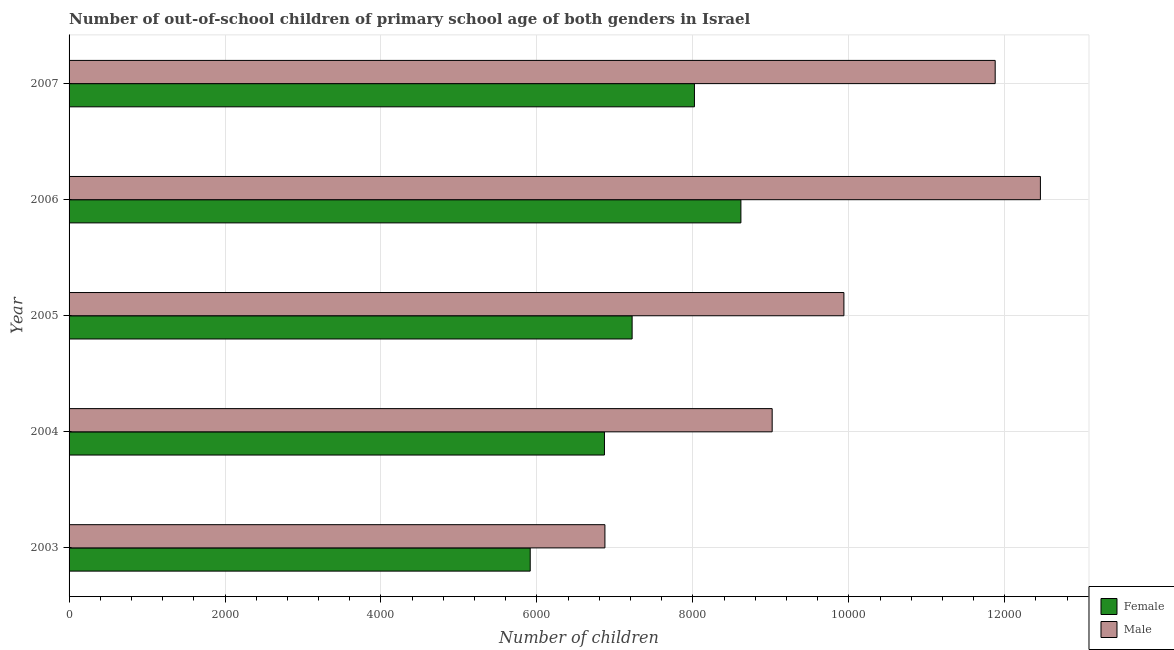Are the number of bars per tick equal to the number of legend labels?
Your response must be concise. Yes. Are the number of bars on each tick of the Y-axis equal?
Your answer should be very brief. Yes. How many bars are there on the 1st tick from the bottom?
Make the answer very short. 2. What is the label of the 3rd group of bars from the top?
Your answer should be very brief. 2005. What is the number of male out-of-school students in 2006?
Your response must be concise. 1.25e+04. Across all years, what is the maximum number of female out-of-school students?
Provide a short and direct response. 8616. Across all years, what is the minimum number of male out-of-school students?
Offer a terse response. 6872. In which year was the number of female out-of-school students maximum?
Give a very brief answer. 2006. What is the total number of female out-of-school students in the graph?
Your answer should be compact. 3.66e+04. What is the difference between the number of male out-of-school students in 2005 and that in 2006?
Offer a terse response. -2520. What is the difference between the number of male out-of-school students in 2005 and the number of female out-of-school students in 2007?
Keep it short and to the point. 1917. What is the average number of female out-of-school students per year?
Your answer should be very brief. 7327.4. In the year 2003, what is the difference between the number of female out-of-school students and number of male out-of-school students?
Offer a terse response. -958. What is the ratio of the number of female out-of-school students in 2005 to that in 2006?
Provide a succinct answer. 0.84. What is the difference between the highest and the second highest number of male out-of-school students?
Give a very brief answer. 580. What is the difference between the highest and the lowest number of female out-of-school students?
Keep it short and to the point. 2702. In how many years, is the number of female out-of-school students greater than the average number of female out-of-school students taken over all years?
Keep it short and to the point. 2. Is the sum of the number of female out-of-school students in 2003 and 2004 greater than the maximum number of male out-of-school students across all years?
Give a very brief answer. Yes. What does the 2nd bar from the top in 2006 represents?
Offer a terse response. Female. How many bars are there?
Give a very brief answer. 10. Are the values on the major ticks of X-axis written in scientific E-notation?
Keep it short and to the point. No. How many legend labels are there?
Offer a very short reply. 2. How are the legend labels stacked?
Make the answer very short. Vertical. What is the title of the graph?
Offer a very short reply. Number of out-of-school children of primary school age of both genders in Israel. Does "Start a business" appear as one of the legend labels in the graph?
Provide a succinct answer. No. What is the label or title of the X-axis?
Make the answer very short. Number of children. What is the label or title of the Y-axis?
Provide a short and direct response. Year. What is the Number of children of Female in 2003?
Your response must be concise. 5914. What is the Number of children of Male in 2003?
Your response must be concise. 6872. What is the Number of children in Female in 2004?
Your response must be concise. 6866. What is the Number of children of Male in 2004?
Offer a very short reply. 9017. What is the Number of children in Female in 2005?
Offer a very short reply. 7221. What is the Number of children of Male in 2005?
Your answer should be very brief. 9937. What is the Number of children in Female in 2006?
Offer a very short reply. 8616. What is the Number of children of Male in 2006?
Your answer should be compact. 1.25e+04. What is the Number of children in Female in 2007?
Make the answer very short. 8020. What is the Number of children in Male in 2007?
Keep it short and to the point. 1.19e+04. Across all years, what is the maximum Number of children of Female?
Ensure brevity in your answer.  8616. Across all years, what is the maximum Number of children of Male?
Offer a very short reply. 1.25e+04. Across all years, what is the minimum Number of children in Female?
Your answer should be compact. 5914. Across all years, what is the minimum Number of children of Male?
Your response must be concise. 6872. What is the total Number of children in Female in the graph?
Offer a terse response. 3.66e+04. What is the total Number of children in Male in the graph?
Your response must be concise. 5.02e+04. What is the difference between the Number of children of Female in 2003 and that in 2004?
Your answer should be compact. -952. What is the difference between the Number of children of Male in 2003 and that in 2004?
Offer a very short reply. -2145. What is the difference between the Number of children of Female in 2003 and that in 2005?
Provide a succinct answer. -1307. What is the difference between the Number of children of Male in 2003 and that in 2005?
Your answer should be very brief. -3065. What is the difference between the Number of children in Female in 2003 and that in 2006?
Keep it short and to the point. -2702. What is the difference between the Number of children in Male in 2003 and that in 2006?
Give a very brief answer. -5585. What is the difference between the Number of children of Female in 2003 and that in 2007?
Your answer should be compact. -2106. What is the difference between the Number of children in Male in 2003 and that in 2007?
Keep it short and to the point. -5005. What is the difference between the Number of children in Female in 2004 and that in 2005?
Provide a short and direct response. -355. What is the difference between the Number of children in Male in 2004 and that in 2005?
Your answer should be compact. -920. What is the difference between the Number of children in Female in 2004 and that in 2006?
Make the answer very short. -1750. What is the difference between the Number of children in Male in 2004 and that in 2006?
Provide a short and direct response. -3440. What is the difference between the Number of children of Female in 2004 and that in 2007?
Your response must be concise. -1154. What is the difference between the Number of children in Male in 2004 and that in 2007?
Provide a succinct answer. -2860. What is the difference between the Number of children of Female in 2005 and that in 2006?
Make the answer very short. -1395. What is the difference between the Number of children in Male in 2005 and that in 2006?
Make the answer very short. -2520. What is the difference between the Number of children in Female in 2005 and that in 2007?
Provide a short and direct response. -799. What is the difference between the Number of children of Male in 2005 and that in 2007?
Provide a succinct answer. -1940. What is the difference between the Number of children of Female in 2006 and that in 2007?
Your response must be concise. 596. What is the difference between the Number of children of Male in 2006 and that in 2007?
Provide a short and direct response. 580. What is the difference between the Number of children in Female in 2003 and the Number of children in Male in 2004?
Give a very brief answer. -3103. What is the difference between the Number of children in Female in 2003 and the Number of children in Male in 2005?
Give a very brief answer. -4023. What is the difference between the Number of children in Female in 2003 and the Number of children in Male in 2006?
Ensure brevity in your answer.  -6543. What is the difference between the Number of children of Female in 2003 and the Number of children of Male in 2007?
Your response must be concise. -5963. What is the difference between the Number of children in Female in 2004 and the Number of children in Male in 2005?
Ensure brevity in your answer.  -3071. What is the difference between the Number of children of Female in 2004 and the Number of children of Male in 2006?
Give a very brief answer. -5591. What is the difference between the Number of children in Female in 2004 and the Number of children in Male in 2007?
Offer a terse response. -5011. What is the difference between the Number of children of Female in 2005 and the Number of children of Male in 2006?
Provide a short and direct response. -5236. What is the difference between the Number of children in Female in 2005 and the Number of children in Male in 2007?
Ensure brevity in your answer.  -4656. What is the difference between the Number of children of Female in 2006 and the Number of children of Male in 2007?
Your answer should be very brief. -3261. What is the average Number of children in Female per year?
Provide a succinct answer. 7327.4. What is the average Number of children of Male per year?
Your response must be concise. 1.00e+04. In the year 2003, what is the difference between the Number of children in Female and Number of children in Male?
Ensure brevity in your answer.  -958. In the year 2004, what is the difference between the Number of children of Female and Number of children of Male?
Keep it short and to the point. -2151. In the year 2005, what is the difference between the Number of children of Female and Number of children of Male?
Offer a very short reply. -2716. In the year 2006, what is the difference between the Number of children of Female and Number of children of Male?
Your answer should be very brief. -3841. In the year 2007, what is the difference between the Number of children in Female and Number of children in Male?
Your response must be concise. -3857. What is the ratio of the Number of children in Female in 2003 to that in 2004?
Give a very brief answer. 0.86. What is the ratio of the Number of children in Male in 2003 to that in 2004?
Your response must be concise. 0.76. What is the ratio of the Number of children of Female in 2003 to that in 2005?
Ensure brevity in your answer.  0.82. What is the ratio of the Number of children in Male in 2003 to that in 2005?
Provide a short and direct response. 0.69. What is the ratio of the Number of children in Female in 2003 to that in 2006?
Make the answer very short. 0.69. What is the ratio of the Number of children of Male in 2003 to that in 2006?
Keep it short and to the point. 0.55. What is the ratio of the Number of children of Female in 2003 to that in 2007?
Offer a very short reply. 0.74. What is the ratio of the Number of children in Male in 2003 to that in 2007?
Offer a very short reply. 0.58. What is the ratio of the Number of children of Female in 2004 to that in 2005?
Provide a short and direct response. 0.95. What is the ratio of the Number of children of Male in 2004 to that in 2005?
Make the answer very short. 0.91. What is the ratio of the Number of children of Female in 2004 to that in 2006?
Make the answer very short. 0.8. What is the ratio of the Number of children in Male in 2004 to that in 2006?
Give a very brief answer. 0.72. What is the ratio of the Number of children of Female in 2004 to that in 2007?
Make the answer very short. 0.86. What is the ratio of the Number of children in Male in 2004 to that in 2007?
Provide a succinct answer. 0.76. What is the ratio of the Number of children in Female in 2005 to that in 2006?
Keep it short and to the point. 0.84. What is the ratio of the Number of children in Male in 2005 to that in 2006?
Give a very brief answer. 0.8. What is the ratio of the Number of children in Female in 2005 to that in 2007?
Your response must be concise. 0.9. What is the ratio of the Number of children in Male in 2005 to that in 2007?
Provide a succinct answer. 0.84. What is the ratio of the Number of children of Female in 2006 to that in 2007?
Offer a very short reply. 1.07. What is the ratio of the Number of children of Male in 2006 to that in 2007?
Keep it short and to the point. 1.05. What is the difference between the highest and the second highest Number of children in Female?
Provide a short and direct response. 596. What is the difference between the highest and the second highest Number of children of Male?
Your answer should be very brief. 580. What is the difference between the highest and the lowest Number of children of Female?
Make the answer very short. 2702. What is the difference between the highest and the lowest Number of children of Male?
Offer a terse response. 5585. 